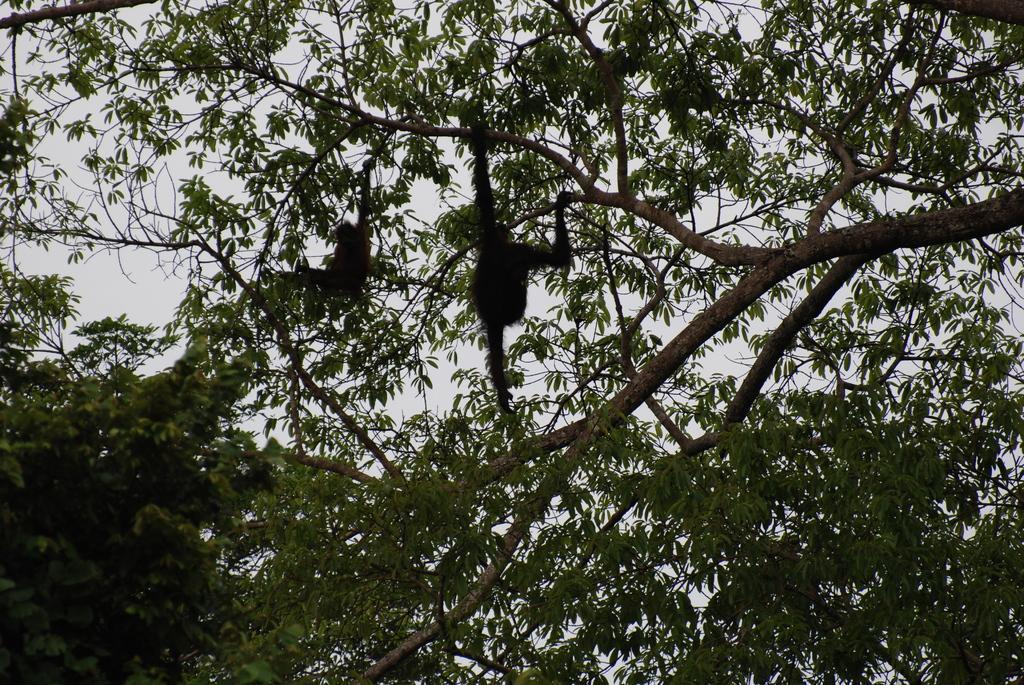Can you describe this image briefly? In the center of the image there are two monkeys on the tree. 